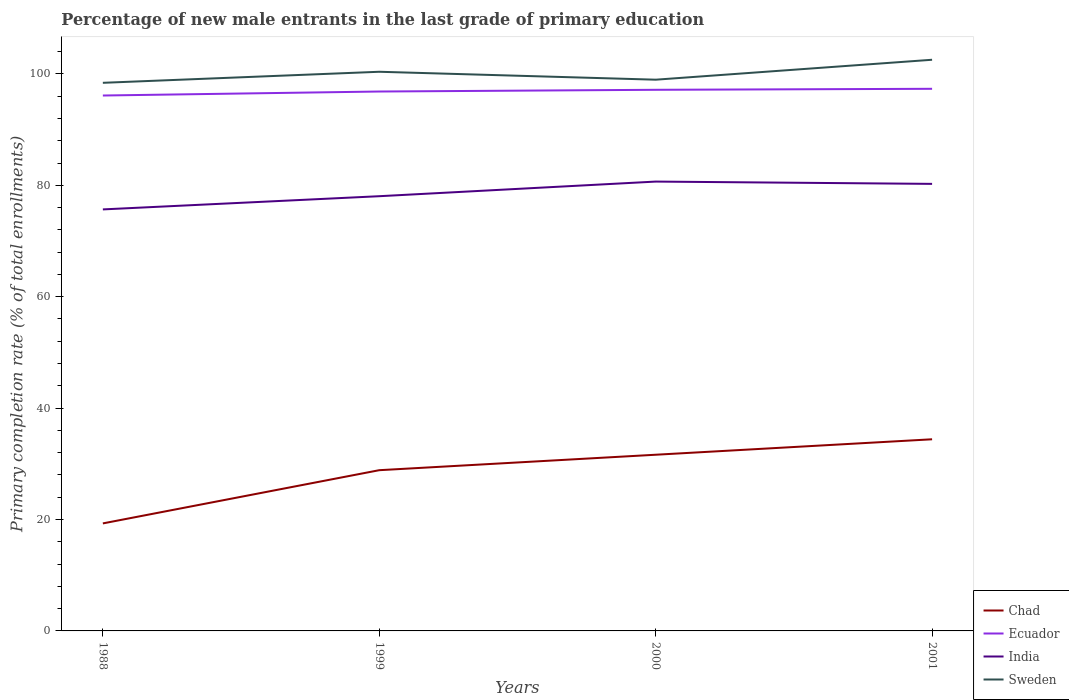Does the line corresponding to India intersect with the line corresponding to Chad?
Your answer should be compact. No. Is the number of lines equal to the number of legend labels?
Offer a very short reply. Yes. Across all years, what is the maximum percentage of new male entrants in Ecuador?
Make the answer very short. 96.12. In which year was the percentage of new male entrants in India maximum?
Offer a very short reply. 1988. What is the total percentage of new male entrants in Sweden in the graph?
Give a very brief answer. -4.14. What is the difference between the highest and the second highest percentage of new male entrants in Chad?
Keep it short and to the point. 15.1. What is the difference between the highest and the lowest percentage of new male entrants in Chad?
Keep it short and to the point. 3. Is the percentage of new male entrants in Ecuador strictly greater than the percentage of new male entrants in Chad over the years?
Your response must be concise. No. How many lines are there?
Provide a short and direct response. 4. What is the difference between two consecutive major ticks on the Y-axis?
Ensure brevity in your answer.  20. Are the values on the major ticks of Y-axis written in scientific E-notation?
Ensure brevity in your answer.  No. Does the graph contain any zero values?
Provide a short and direct response. No. Does the graph contain grids?
Give a very brief answer. No. Where does the legend appear in the graph?
Make the answer very short. Bottom right. How are the legend labels stacked?
Your answer should be compact. Vertical. What is the title of the graph?
Make the answer very short. Percentage of new male entrants in the last grade of primary education. Does "Egypt, Arab Rep." appear as one of the legend labels in the graph?
Offer a terse response. No. What is the label or title of the X-axis?
Offer a very short reply. Years. What is the label or title of the Y-axis?
Your answer should be compact. Primary completion rate (% of total enrollments). What is the Primary completion rate (% of total enrollments) in Chad in 1988?
Make the answer very short. 19.3. What is the Primary completion rate (% of total enrollments) of Ecuador in 1988?
Keep it short and to the point. 96.12. What is the Primary completion rate (% of total enrollments) in India in 1988?
Your response must be concise. 75.67. What is the Primary completion rate (% of total enrollments) of Sweden in 1988?
Give a very brief answer. 98.4. What is the Primary completion rate (% of total enrollments) in Chad in 1999?
Your answer should be compact. 28.86. What is the Primary completion rate (% of total enrollments) in Ecuador in 1999?
Provide a succinct answer. 96.84. What is the Primary completion rate (% of total enrollments) in India in 1999?
Offer a very short reply. 78.04. What is the Primary completion rate (% of total enrollments) of Sweden in 1999?
Provide a succinct answer. 100.38. What is the Primary completion rate (% of total enrollments) in Chad in 2000?
Your response must be concise. 31.63. What is the Primary completion rate (% of total enrollments) of Ecuador in 2000?
Offer a terse response. 97.15. What is the Primary completion rate (% of total enrollments) in India in 2000?
Provide a succinct answer. 80.67. What is the Primary completion rate (% of total enrollments) of Sweden in 2000?
Make the answer very short. 98.96. What is the Primary completion rate (% of total enrollments) in Chad in 2001?
Your response must be concise. 34.4. What is the Primary completion rate (% of total enrollments) in Ecuador in 2001?
Keep it short and to the point. 97.33. What is the Primary completion rate (% of total enrollments) of India in 2001?
Make the answer very short. 80.26. What is the Primary completion rate (% of total enrollments) of Sweden in 2001?
Give a very brief answer. 102.54. Across all years, what is the maximum Primary completion rate (% of total enrollments) of Chad?
Keep it short and to the point. 34.4. Across all years, what is the maximum Primary completion rate (% of total enrollments) of Ecuador?
Your answer should be compact. 97.33. Across all years, what is the maximum Primary completion rate (% of total enrollments) of India?
Keep it short and to the point. 80.67. Across all years, what is the maximum Primary completion rate (% of total enrollments) in Sweden?
Ensure brevity in your answer.  102.54. Across all years, what is the minimum Primary completion rate (% of total enrollments) of Chad?
Offer a terse response. 19.3. Across all years, what is the minimum Primary completion rate (% of total enrollments) in Ecuador?
Your answer should be compact. 96.12. Across all years, what is the minimum Primary completion rate (% of total enrollments) in India?
Offer a very short reply. 75.67. Across all years, what is the minimum Primary completion rate (% of total enrollments) of Sweden?
Your response must be concise. 98.4. What is the total Primary completion rate (% of total enrollments) in Chad in the graph?
Your answer should be compact. 114.19. What is the total Primary completion rate (% of total enrollments) of Ecuador in the graph?
Ensure brevity in your answer.  387.43. What is the total Primary completion rate (% of total enrollments) in India in the graph?
Offer a very short reply. 314.64. What is the total Primary completion rate (% of total enrollments) of Sweden in the graph?
Offer a very short reply. 400.29. What is the difference between the Primary completion rate (% of total enrollments) of Chad in 1988 and that in 1999?
Provide a short and direct response. -9.56. What is the difference between the Primary completion rate (% of total enrollments) in Ecuador in 1988 and that in 1999?
Your answer should be compact. -0.72. What is the difference between the Primary completion rate (% of total enrollments) of India in 1988 and that in 1999?
Keep it short and to the point. -2.37. What is the difference between the Primary completion rate (% of total enrollments) in Sweden in 1988 and that in 1999?
Your response must be concise. -1.98. What is the difference between the Primary completion rate (% of total enrollments) in Chad in 1988 and that in 2000?
Your response must be concise. -12.33. What is the difference between the Primary completion rate (% of total enrollments) of Ecuador in 1988 and that in 2000?
Keep it short and to the point. -1.03. What is the difference between the Primary completion rate (% of total enrollments) of India in 1988 and that in 2000?
Offer a terse response. -5. What is the difference between the Primary completion rate (% of total enrollments) in Sweden in 1988 and that in 2000?
Ensure brevity in your answer.  -0.56. What is the difference between the Primary completion rate (% of total enrollments) of Chad in 1988 and that in 2001?
Provide a short and direct response. -15.1. What is the difference between the Primary completion rate (% of total enrollments) in Ecuador in 1988 and that in 2001?
Ensure brevity in your answer.  -1.21. What is the difference between the Primary completion rate (% of total enrollments) of India in 1988 and that in 2001?
Offer a terse response. -4.58. What is the difference between the Primary completion rate (% of total enrollments) in Sweden in 1988 and that in 2001?
Keep it short and to the point. -4.14. What is the difference between the Primary completion rate (% of total enrollments) in Chad in 1999 and that in 2000?
Offer a terse response. -2.77. What is the difference between the Primary completion rate (% of total enrollments) of Ecuador in 1999 and that in 2000?
Make the answer very short. -0.31. What is the difference between the Primary completion rate (% of total enrollments) in India in 1999 and that in 2000?
Provide a succinct answer. -2.63. What is the difference between the Primary completion rate (% of total enrollments) in Sweden in 1999 and that in 2000?
Your answer should be compact. 1.42. What is the difference between the Primary completion rate (% of total enrollments) of Chad in 1999 and that in 2001?
Your response must be concise. -5.55. What is the difference between the Primary completion rate (% of total enrollments) in Ecuador in 1999 and that in 2001?
Ensure brevity in your answer.  -0.49. What is the difference between the Primary completion rate (% of total enrollments) in India in 1999 and that in 2001?
Offer a terse response. -2.21. What is the difference between the Primary completion rate (% of total enrollments) of Sweden in 1999 and that in 2001?
Offer a very short reply. -2.16. What is the difference between the Primary completion rate (% of total enrollments) of Chad in 2000 and that in 2001?
Ensure brevity in your answer.  -2.77. What is the difference between the Primary completion rate (% of total enrollments) of Ecuador in 2000 and that in 2001?
Your answer should be very brief. -0.18. What is the difference between the Primary completion rate (% of total enrollments) in India in 2000 and that in 2001?
Offer a very short reply. 0.41. What is the difference between the Primary completion rate (% of total enrollments) of Sweden in 2000 and that in 2001?
Make the answer very short. -3.58. What is the difference between the Primary completion rate (% of total enrollments) of Chad in 1988 and the Primary completion rate (% of total enrollments) of Ecuador in 1999?
Give a very brief answer. -77.54. What is the difference between the Primary completion rate (% of total enrollments) in Chad in 1988 and the Primary completion rate (% of total enrollments) in India in 1999?
Offer a terse response. -58.74. What is the difference between the Primary completion rate (% of total enrollments) in Chad in 1988 and the Primary completion rate (% of total enrollments) in Sweden in 1999?
Ensure brevity in your answer.  -81.08. What is the difference between the Primary completion rate (% of total enrollments) of Ecuador in 1988 and the Primary completion rate (% of total enrollments) of India in 1999?
Your answer should be compact. 18.08. What is the difference between the Primary completion rate (% of total enrollments) of Ecuador in 1988 and the Primary completion rate (% of total enrollments) of Sweden in 1999?
Provide a short and direct response. -4.26. What is the difference between the Primary completion rate (% of total enrollments) of India in 1988 and the Primary completion rate (% of total enrollments) of Sweden in 1999?
Ensure brevity in your answer.  -24.71. What is the difference between the Primary completion rate (% of total enrollments) of Chad in 1988 and the Primary completion rate (% of total enrollments) of Ecuador in 2000?
Your response must be concise. -77.85. What is the difference between the Primary completion rate (% of total enrollments) in Chad in 1988 and the Primary completion rate (% of total enrollments) in India in 2000?
Provide a short and direct response. -61.37. What is the difference between the Primary completion rate (% of total enrollments) in Chad in 1988 and the Primary completion rate (% of total enrollments) in Sweden in 2000?
Keep it short and to the point. -79.66. What is the difference between the Primary completion rate (% of total enrollments) of Ecuador in 1988 and the Primary completion rate (% of total enrollments) of India in 2000?
Your response must be concise. 15.45. What is the difference between the Primary completion rate (% of total enrollments) in Ecuador in 1988 and the Primary completion rate (% of total enrollments) in Sweden in 2000?
Offer a terse response. -2.84. What is the difference between the Primary completion rate (% of total enrollments) of India in 1988 and the Primary completion rate (% of total enrollments) of Sweden in 2000?
Ensure brevity in your answer.  -23.29. What is the difference between the Primary completion rate (% of total enrollments) in Chad in 1988 and the Primary completion rate (% of total enrollments) in Ecuador in 2001?
Provide a short and direct response. -78.02. What is the difference between the Primary completion rate (% of total enrollments) of Chad in 1988 and the Primary completion rate (% of total enrollments) of India in 2001?
Make the answer very short. -60.95. What is the difference between the Primary completion rate (% of total enrollments) in Chad in 1988 and the Primary completion rate (% of total enrollments) in Sweden in 2001?
Give a very brief answer. -83.24. What is the difference between the Primary completion rate (% of total enrollments) in Ecuador in 1988 and the Primary completion rate (% of total enrollments) in India in 2001?
Your response must be concise. 15.86. What is the difference between the Primary completion rate (% of total enrollments) in Ecuador in 1988 and the Primary completion rate (% of total enrollments) in Sweden in 2001?
Keep it short and to the point. -6.42. What is the difference between the Primary completion rate (% of total enrollments) of India in 1988 and the Primary completion rate (% of total enrollments) of Sweden in 2001?
Your answer should be very brief. -26.87. What is the difference between the Primary completion rate (% of total enrollments) in Chad in 1999 and the Primary completion rate (% of total enrollments) in Ecuador in 2000?
Offer a very short reply. -68.29. What is the difference between the Primary completion rate (% of total enrollments) of Chad in 1999 and the Primary completion rate (% of total enrollments) of India in 2000?
Your answer should be compact. -51.81. What is the difference between the Primary completion rate (% of total enrollments) of Chad in 1999 and the Primary completion rate (% of total enrollments) of Sweden in 2000?
Give a very brief answer. -70.1. What is the difference between the Primary completion rate (% of total enrollments) of Ecuador in 1999 and the Primary completion rate (% of total enrollments) of India in 2000?
Keep it short and to the point. 16.17. What is the difference between the Primary completion rate (% of total enrollments) of Ecuador in 1999 and the Primary completion rate (% of total enrollments) of Sweden in 2000?
Offer a very short reply. -2.12. What is the difference between the Primary completion rate (% of total enrollments) of India in 1999 and the Primary completion rate (% of total enrollments) of Sweden in 2000?
Your answer should be compact. -20.92. What is the difference between the Primary completion rate (% of total enrollments) in Chad in 1999 and the Primary completion rate (% of total enrollments) in Ecuador in 2001?
Make the answer very short. -68.47. What is the difference between the Primary completion rate (% of total enrollments) in Chad in 1999 and the Primary completion rate (% of total enrollments) in India in 2001?
Offer a very short reply. -51.4. What is the difference between the Primary completion rate (% of total enrollments) in Chad in 1999 and the Primary completion rate (% of total enrollments) in Sweden in 2001?
Offer a very short reply. -73.68. What is the difference between the Primary completion rate (% of total enrollments) in Ecuador in 1999 and the Primary completion rate (% of total enrollments) in India in 2001?
Keep it short and to the point. 16.58. What is the difference between the Primary completion rate (% of total enrollments) in Ecuador in 1999 and the Primary completion rate (% of total enrollments) in Sweden in 2001?
Provide a succinct answer. -5.7. What is the difference between the Primary completion rate (% of total enrollments) in India in 1999 and the Primary completion rate (% of total enrollments) in Sweden in 2001?
Offer a very short reply. -24.5. What is the difference between the Primary completion rate (% of total enrollments) of Chad in 2000 and the Primary completion rate (% of total enrollments) of Ecuador in 2001?
Keep it short and to the point. -65.69. What is the difference between the Primary completion rate (% of total enrollments) in Chad in 2000 and the Primary completion rate (% of total enrollments) in India in 2001?
Give a very brief answer. -48.62. What is the difference between the Primary completion rate (% of total enrollments) of Chad in 2000 and the Primary completion rate (% of total enrollments) of Sweden in 2001?
Provide a short and direct response. -70.91. What is the difference between the Primary completion rate (% of total enrollments) of Ecuador in 2000 and the Primary completion rate (% of total enrollments) of India in 2001?
Ensure brevity in your answer.  16.89. What is the difference between the Primary completion rate (% of total enrollments) in Ecuador in 2000 and the Primary completion rate (% of total enrollments) in Sweden in 2001?
Keep it short and to the point. -5.39. What is the difference between the Primary completion rate (% of total enrollments) of India in 2000 and the Primary completion rate (% of total enrollments) of Sweden in 2001?
Your answer should be compact. -21.87. What is the average Primary completion rate (% of total enrollments) in Chad per year?
Offer a very short reply. 28.55. What is the average Primary completion rate (% of total enrollments) of Ecuador per year?
Your answer should be very brief. 96.86. What is the average Primary completion rate (% of total enrollments) in India per year?
Keep it short and to the point. 78.66. What is the average Primary completion rate (% of total enrollments) of Sweden per year?
Provide a succinct answer. 100.07. In the year 1988, what is the difference between the Primary completion rate (% of total enrollments) in Chad and Primary completion rate (% of total enrollments) in Ecuador?
Provide a short and direct response. -76.82. In the year 1988, what is the difference between the Primary completion rate (% of total enrollments) in Chad and Primary completion rate (% of total enrollments) in India?
Ensure brevity in your answer.  -56.37. In the year 1988, what is the difference between the Primary completion rate (% of total enrollments) in Chad and Primary completion rate (% of total enrollments) in Sweden?
Offer a terse response. -79.1. In the year 1988, what is the difference between the Primary completion rate (% of total enrollments) in Ecuador and Primary completion rate (% of total enrollments) in India?
Give a very brief answer. 20.45. In the year 1988, what is the difference between the Primary completion rate (% of total enrollments) in Ecuador and Primary completion rate (% of total enrollments) in Sweden?
Ensure brevity in your answer.  -2.28. In the year 1988, what is the difference between the Primary completion rate (% of total enrollments) of India and Primary completion rate (% of total enrollments) of Sweden?
Give a very brief answer. -22.73. In the year 1999, what is the difference between the Primary completion rate (% of total enrollments) of Chad and Primary completion rate (% of total enrollments) of Ecuador?
Keep it short and to the point. -67.98. In the year 1999, what is the difference between the Primary completion rate (% of total enrollments) in Chad and Primary completion rate (% of total enrollments) in India?
Make the answer very short. -49.19. In the year 1999, what is the difference between the Primary completion rate (% of total enrollments) in Chad and Primary completion rate (% of total enrollments) in Sweden?
Ensure brevity in your answer.  -71.53. In the year 1999, what is the difference between the Primary completion rate (% of total enrollments) in Ecuador and Primary completion rate (% of total enrollments) in India?
Your answer should be very brief. 18.79. In the year 1999, what is the difference between the Primary completion rate (% of total enrollments) in Ecuador and Primary completion rate (% of total enrollments) in Sweden?
Provide a succinct answer. -3.55. In the year 1999, what is the difference between the Primary completion rate (% of total enrollments) of India and Primary completion rate (% of total enrollments) of Sweden?
Your answer should be compact. -22.34. In the year 2000, what is the difference between the Primary completion rate (% of total enrollments) in Chad and Primary completion rate (% of total enrollments) in Ecuador?
Keep it short and to the point. -65.52. In the year 2000, what is the difference between the Primary completion rate (% of total enrollments) of Chad and Primary completion rate (% of total enrollments) of India?
Make the answer very short. -49.04. In the year 2000, what is the difference between the Primary completion rate (% of total enrollments) of Chad and Primary completion rate (% of total enrollments) of Sweden?
Keep it short and to the point. -67.33. In the year 2000, what is the difference between the Primary completion rate (% of total enrollments) in Ecuador and Primary completion rate (% of total enrollments) in India?
Your answer should be compact. 16.48. In the year 2000, what is the difference between the Primary completion rate (% of total enrollments) in Ecuador and Primary completion rate (% of total enrollments) in Sweden?
Offer a terse response. -1.81. In the year 2000, what is the difference between the Primary completion rate (% of total enrollments) in India and Primary completion rate (% of total enrollments) in Sweden?
Your response must be concise. -18.29. In the year 2001, what is the difference between the Primary completion rate (% of total enrollments) of Chad and Primary completion rate (% of total enrollments) of Ecuador?
Offer a terse response. -62.92. In the year 2001, what is the difference between the Primary completion rate (% of total enrollments) of Chad and Primary completion rate (% of total enrollments) of India?
Your answer should be very brief. -45.85. In the year 2001, what is the difference between the Primary completion rate (% of total enrollments) of Chad and Primary completion rate (% of total enrollments) of Sweden?
Ensure brevity in your answer.  -68.14. In the year 2001, what is the difference between the Primary completion rate (% of total enrollments) in Ecuador and Primary completion rate (% of total enrollments) in India?
Provide a short and direct response. 17.07. In the year 2001, what is the difference between the Primary completion rate (% of total enrollments) of Ecuador and Primary completion rate (% of total enrollments) of Sweden?
Provide a short and direct response. -5.21. In the year 2001, what is the difference between the Primary completion rate (% of total enrollments) in India and Primary completion rate (% of total enrollments) in Sweden?
Your answer should be compact. -22.28. What is the ratio of the Primary completion rate (% of total enrollments) of Chad in 1988 to that in 1999?
Give a very brief answer. 0.67. What is the ratio of the Primary completion rate (% of total enrollments) of India in 1988 to that in 1999?
Make the answer very short. 0.97. What is the ratio of the Primary completion rate (% of total enrollments) of Sweden in 1988 to that in 1999?
Offer a terse response. 0.98. What is the ratio of the Primary completion rate (% of total enrollments) in Chad in 1988 to that in 2000?
Make the answer very short. 0.61. What is the ratio of the Primary completion rate (% of total enrollments) of India in 1988 to that in 2000?
Ensure brevity in your answer.  0.94. What is the ratio of the Primary completion rate (% of total enrollments) in Chad in 1988 to that in 2001?
Give a very brief answer. 0.56. What is the ratio of the Primary completion rate (% of total enrollments) of Ecuador in 1988 to that in 2001?
Your answer should be compact. 0.99. What is the ratio of the Primary completion rate (% of total enrollments) of India in 1988 to that in 2001?
Your answer should be very brief. 0.94. What is the ratio of the Primary completion rate (% of total enrollments) in Sweden in 1988 to that in 2001?
Your answer should be compact. 0.96. What is the ratio of the Primary completion rate (% of total enrollments) in Chad in 1999 to that in 2000?
Ensure brevity in your answer.  0.91. What is the ratio of the Primary completion rate (% of total enrollments) in Ecuador in 1999 to that in 2000?
Your answer should be very brief. 1. What is the ratio of the Primary completion rate (% of total enrollments) of India in 1999 to that in 2000?
Offer a very short reply. 0.97. What is the ratio of the Primary completion rate (% of total enrollments) of Sweden in 1999 to that in 2000?
Offer a very short reply. 1.01. What is the ratio of the Primary completion rate (% of total enrollments) in Chad in 1999 to that in 2001?
Your answer should be compact. 0.84. What is the ratio of the Primary completion rate (% of total enrollments) of Ecuador in 1999 to that in 2001?
Ensure brevity in your answer.  0.99. What is the ratio of the Primary completion rate (% of total enrollments) of India in 1999 to that in 2001?
Provide a succinct answer. 0.97. What is the ratio of the Primary completion rate (% of total enrollments) in Sweden in 1999 to that in 2001?
Make the answer very short. 0.98. What is the ratio of the Primary completion rate (% of total enrollments) in Chad in 2000 to that in 2001?
Provide a short and direct response. 0.92. What is the ratio of the Primary completion rate (% of total enrollments) of Ecuador in 2000 to that in 2001?
Keep it short and to the point. 1. What is the ratio of the Primary completion rate (% of total enrollments) in Sweden in 2000 to that in 2001?
Offer a terse response. 0.97. What is the difference between the highest and the second highest Primary completion rate (% of total enrollments) in Chad?
Keep it short and to the point. 2.77. What is the difference between the highest and the second highest Primary completion rate (% of total enrollments) of Ecuador?
Your answer should be compact. 0.18. What is the difference between the highest and the second highest Primary completion rate (% of total enrollments) of India?
Provide a succinct answer. 0.41. What is the difference between the highest and the second highest Primary completion rate (% of total enrollments) of Sweden?
Your response must be concise. 2.16. What is the difference between the highest and the lowest Primary completion rate (% of total enrollments) in Chad?
Your answer should be very brief. 15.1. What is the difference between the highest and the lowest Primary completion rate (% of total enrollments) in Ecuador?
Offer a very short reply. 1.21. What is the difference between the highest and the lowest Primary completion rate (% of total enrollments) in India?
Keep it short and to the point. 5. What is the difference between the highest and the lowest Primary completion rate (% of total enrollments) of Sweden?
Ensure brevity in your answer.  4.14. 